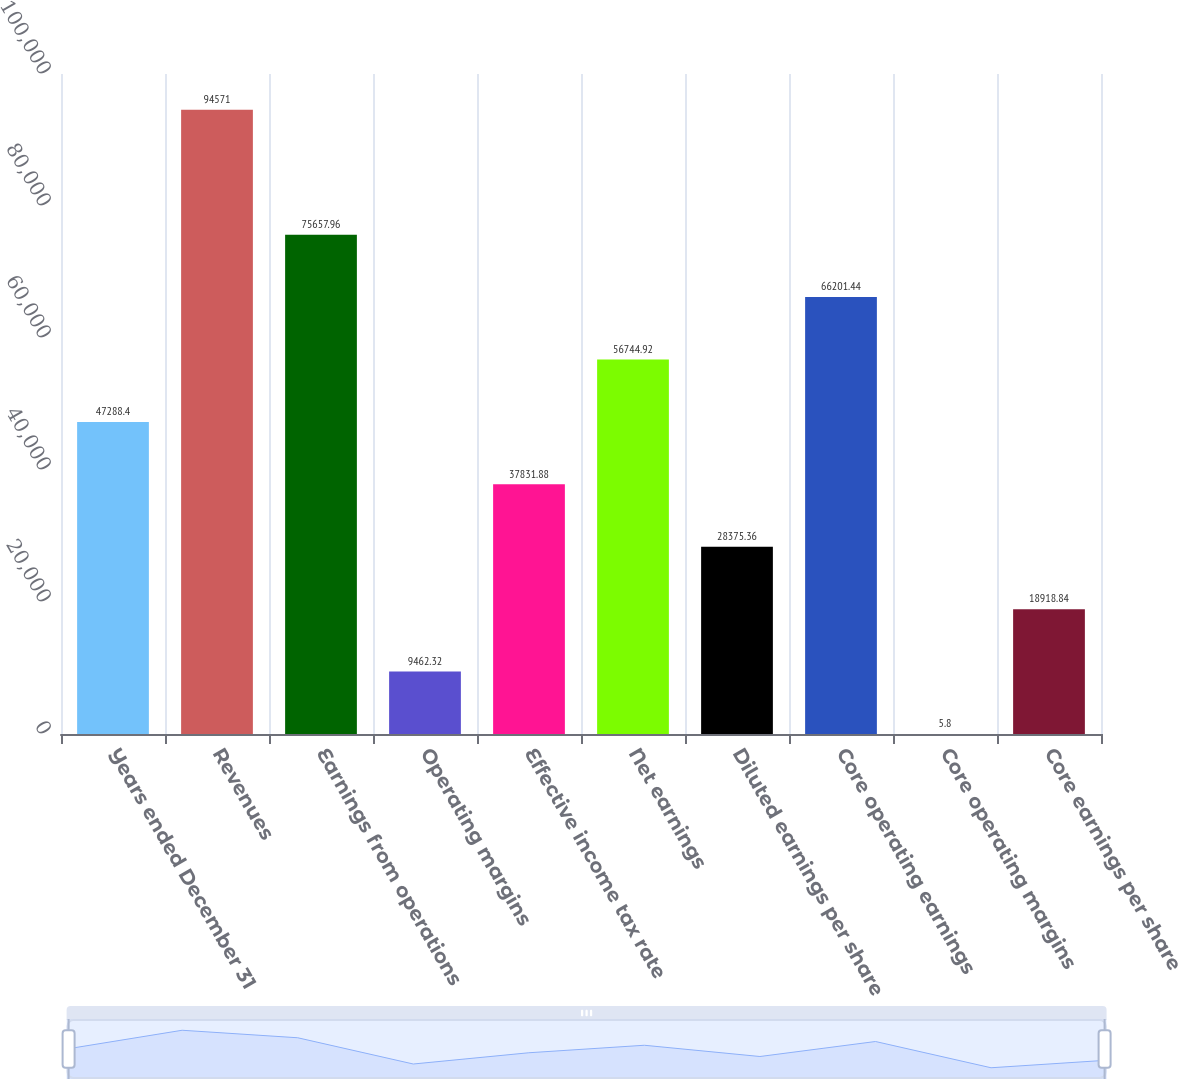Convert chart. <chart><loc_0><loc_0><loc_500><loc_500><bar_chart><fcel>Years ended December 31<fcel>Revenues<fcel>Earnings from operations<fcel>Operating margins<fcel>Effective income tax rate<fcel>Net earnings<fcel>Diluted earnings per share<fcel>Core operating earnings<fcel>Core operating margins<fcel>Core earnings per share<nl><fcel>47288.4<fcel>94571<fcel>75658<fcel>9462.32<fcel>37831.9<fcel>56744.9<fcel>28375.4<fcel>66201.4<fcel>5.8<fcel>18918.8<nl></chart> 